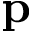<formula> <loc_0><loc_0><loc_500><loc_500>\mathbf p</formula> 